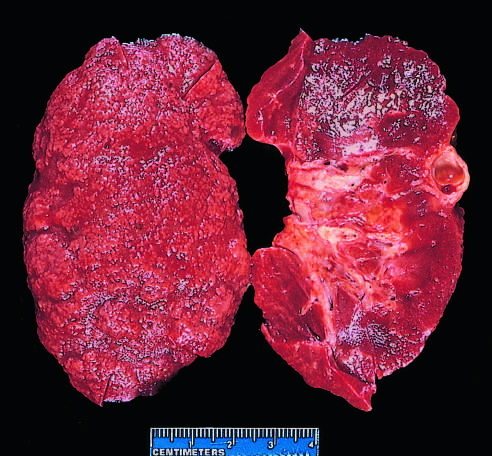what include some irregular depressions, the result of pyelonephritis, and an incidental cortical cyst far (right)?
Answer the question using a single word or phrase. Additional features 